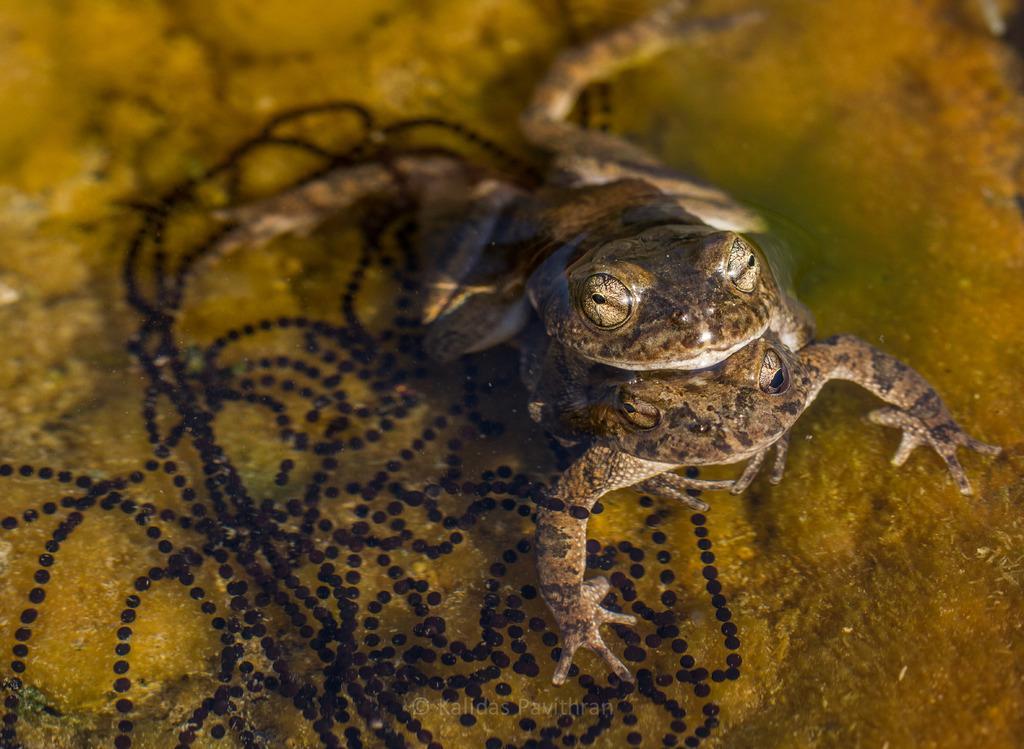How would you summarize this image in a sentence or two? In the image in the center, we can see water. In the water, we can see two drugs, which are in brown color. 